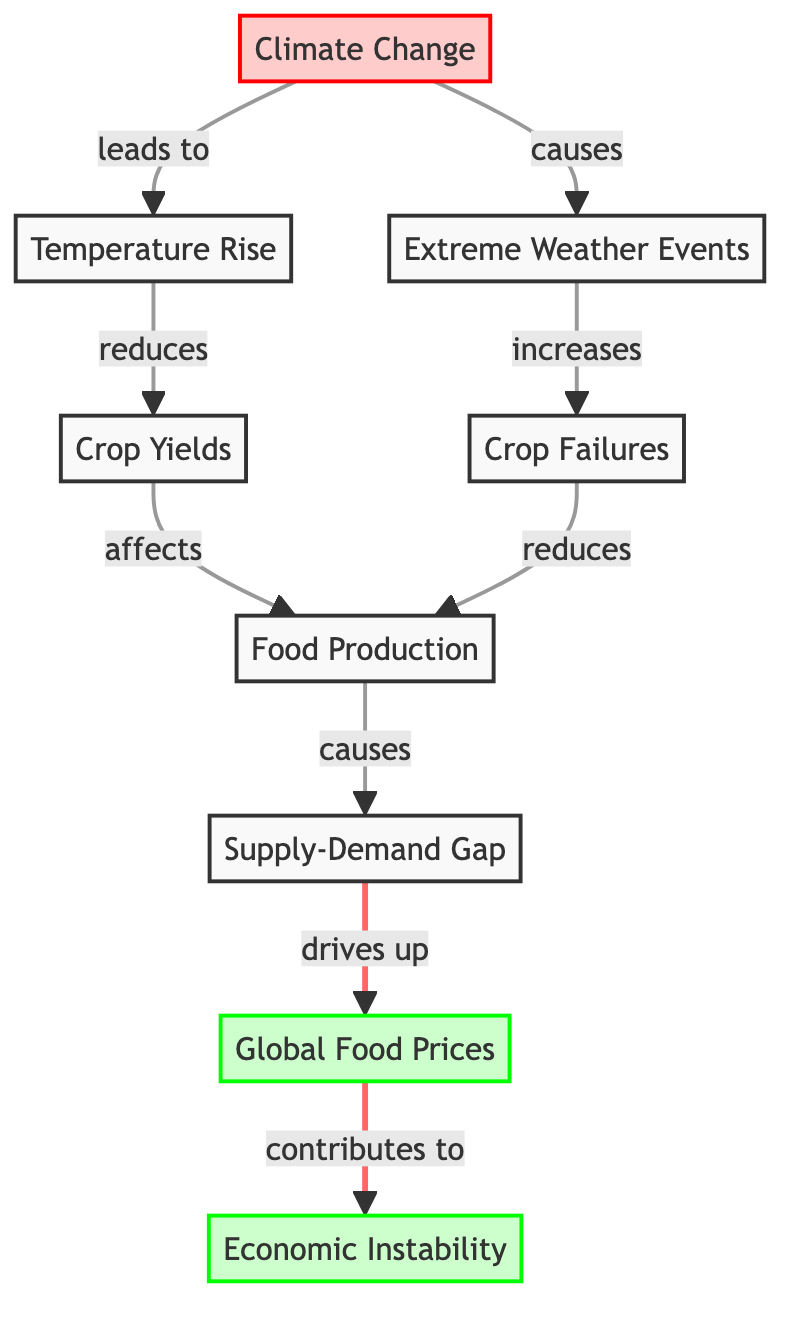What is the first node in the diagram? The first node in the diagram is "Climate Change." This is evident as it is the starting point of the flow leading to other nodes.
Answer: Climate Change How many distinct nodes are there in the diagram? The diagram consists of 8 distinct nodes: Climate Change, Temperature Rise, Extreme Weather Events, Crop Yields, Crop Failures, Food Production, Supply-Demand Gap, and Global Food Prices. Counting each of these nodes results in a total of 8.
Answer: 8 What effect does temperature rise have on crop yields? According to the diagram, temperature rise reduces crop yields. This is indicated by the directional arrow pointing from "Temperature Rise" to "Crop Yields" with a label stating "reduces."
Answer: reduces Which node is affected by both crop yields and crop failures? The node affected by both crop yields and crop failures is "Food Production." This can be seen from the arrows leading to "Food Production" from both "Crop Yields" and "Crop Failures."
Answer: Food Production What is the relationship between supply-demand gap and global food prices? The relationship is that the supply-demand gap drives up global food prices. This is illustrated by the arrow from "Supply-Demand Gap" to "Global Food Prices" with an accompanying label that states "drives up."
Answer: drives up How does climate change influence economic instability? Climate change influences economic instability indirectly through several steps: it first causes temperature rise and extreme weather, which lead to reduced crop yields and increased crop failures. These decrease food production, resulting in a supply-demand gap that eventually drives up global food prices, contributing to economic instability.
Answer: contributes to What causes the supply-demand gap in this diagram? The supply-demand gap is caused by food production, which is affected by both crop yields and crop failures. Specifically, lower crop yields and higher crop failures lead to reduced food production, creating the supply-demand gap.
Answer: food production What two factors lead to reduced crop yields? The two factors that lead to reduced crop yields are temperature rise and extreme weather events. This is clearly stated in the diagram with arrows indicating that both factors reduce crop yields.
Answer: temperature rise and extreme weather events Which node has a direct effect on economic instability? The node with a direct effect on economic instability is "Global Food Prices." The arrow from "Global Food Prices" to "Economic Instability" shows that this node contributes directly to economic instability.
Answer: Global Food Prices 